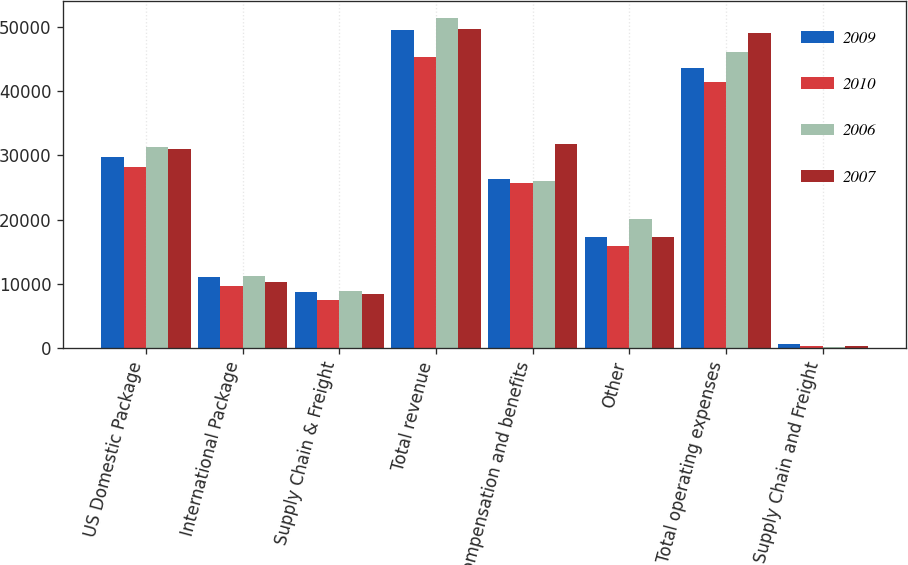Convert chart to OTSL. <chart><loc_0><loc_0><loc_500><loc_500><stacked_bar_chart><ecel><fcel>US Domestic Package<fcel>International Package<fcel>Supply Chain & Freight<fcel>Total revenue<fcel>Compensation and benefits<fcel>Other<fcel>Total operating expenses<fcel>Supply Chain and Freight<nl><fcel>2009<fcel>29742<fcel>11133<fcel>8670<fcel>49545<fcel>26324<fcel>17347<fcel>43671<fcel>597<nl><fcel>2010<fcel>28158<fcel>9699<fcel>7440<fcel>45297<fcel>25640<fcel>15856<fcel>41496<fcel>296<nl><fcel>2006<fcel>31278<fcel>11293<fcel>8915<fcel>51486<fcel>26063<fcel>20041<fcel>46104<fcel>105<nl><fcel>2007<fcel>30985<fcel>10281<fcel>8426<fcel>49692<fcel>31745<fcel>17369<fcel>49114<fcel>278<nl></chart> 